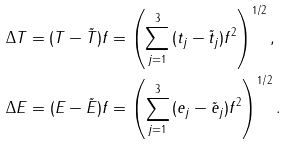<formula> <loc_0><loc_0><loc_500><loc_500>& \Delta T = \| ( T - { \tilde { T } } ) f \| = \left ( \sum _ { j = 1 } ^ { 3 } \| ( t _ { j } - { \tilde { t } } _ { j } ) f \| ^ { 2 } \right ) ^ { 1 / 2 } , \\ & \Delta E = \| ( E - { \tilde { E } } ) f \| = \left ( \sum _ { j = 1 } ^ { 3 } \| ( e _ { j } - { \tilde { e } } _ { j } ) f \| ^ { 2 } \right ) ^ { 1 / 2 } .</formula> 